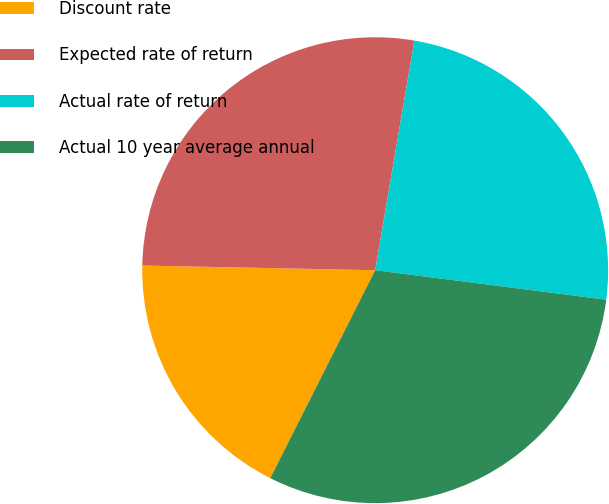<chart> <loc_0><loc_0><loc_500><loc_500><pie_chart><fcel>Discount rate<fcel>Expected rate of return<fcel>Actual rate of return<fcel>Actual 10 year average annual<nl><fcel>17.88%<fcel>27.37%<fcel>24.33%<fcel>30.41%<nl></chart> 